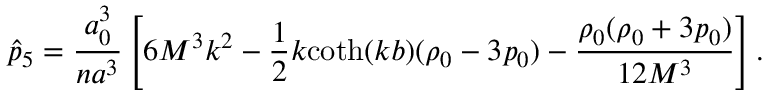<formula> <loc_0><loc_0><loc_500><loc_500>\hat { p } _ { 5 } = \frac { a _ { 0 } ^ { 3 } } { n a ^ { 3 } } \left [ 6 M ^ { 3 } k ^ { 2 } - \frac { 1 } { 2 } k c o t h ( k b ) ( \rho _ { 0 } - 3 p _ { 0 } ) - \frac { \rho _ { 0 } ( \rho _ { 0 } + 3 p _ { 0 } ) } { 1 2 M ^ { 3 } } \right ] .</formula> 